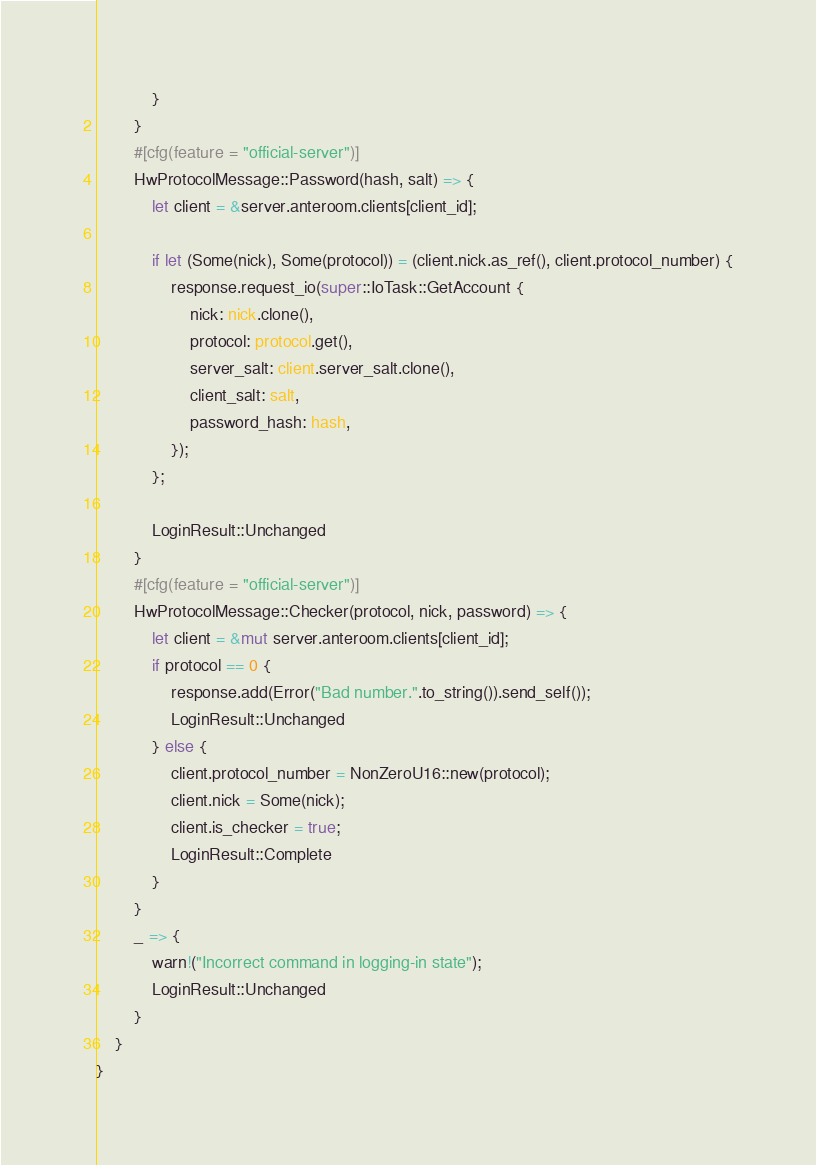Convert code to text. <code><loc_0><loc_0><loc_500><loc_500><_Rust_>            }
        }
        #[cfg(feature = "official-server")]
        HwProtocolMessage::Password(hash, salt) => {
            let client = &server.anteroom.clients[client_id];

            if let (Some(nick), Some(protocol)) = (client.nick.as_ref(), client.protocol_number) {
                response.request_io(super::IoTask::GetAccount {
                    nick: nick.clone(),
                    protocol: protocol.get(),
                    server_salt: client.server_salt.clone(),
                    client_salt: salt,
                    password_hash: hash,
                });
            };

            LoginResult::Unchanged
        }
        #[cfg(feature = "official-server")]
        HwProtocolMessage::Checker(protocol, nick, password) => {
            let client = &mut server.anteroom.clients[client_id];
            if protocol == 0 {
                response.add(Error("Bad number.".to_string()).send_self());
                LoginResult::Unchanged
            } else {
                client.protocol_number = NonZeroU16::new(protocol);
                client.nick = Some(nick);
                client.is_checker = true;
                LoginResult::Complete
            }
        }
        _ => {
            warn!("Incorrect command in logging-in state");
            LoginResult::Unchanged
        }
    }
}
</code> 